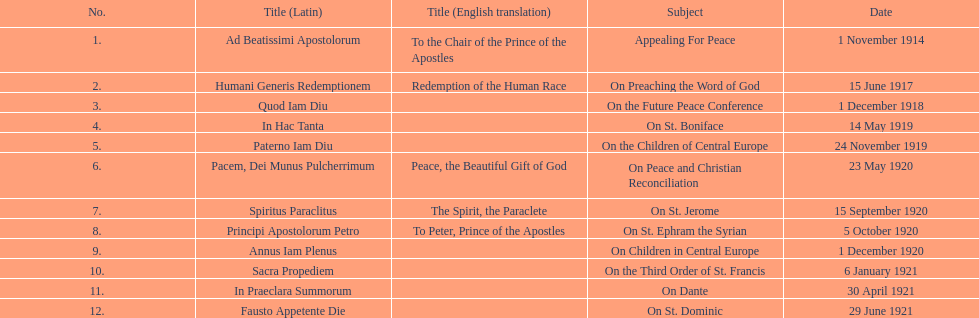How many titles have a date in november? 2. 